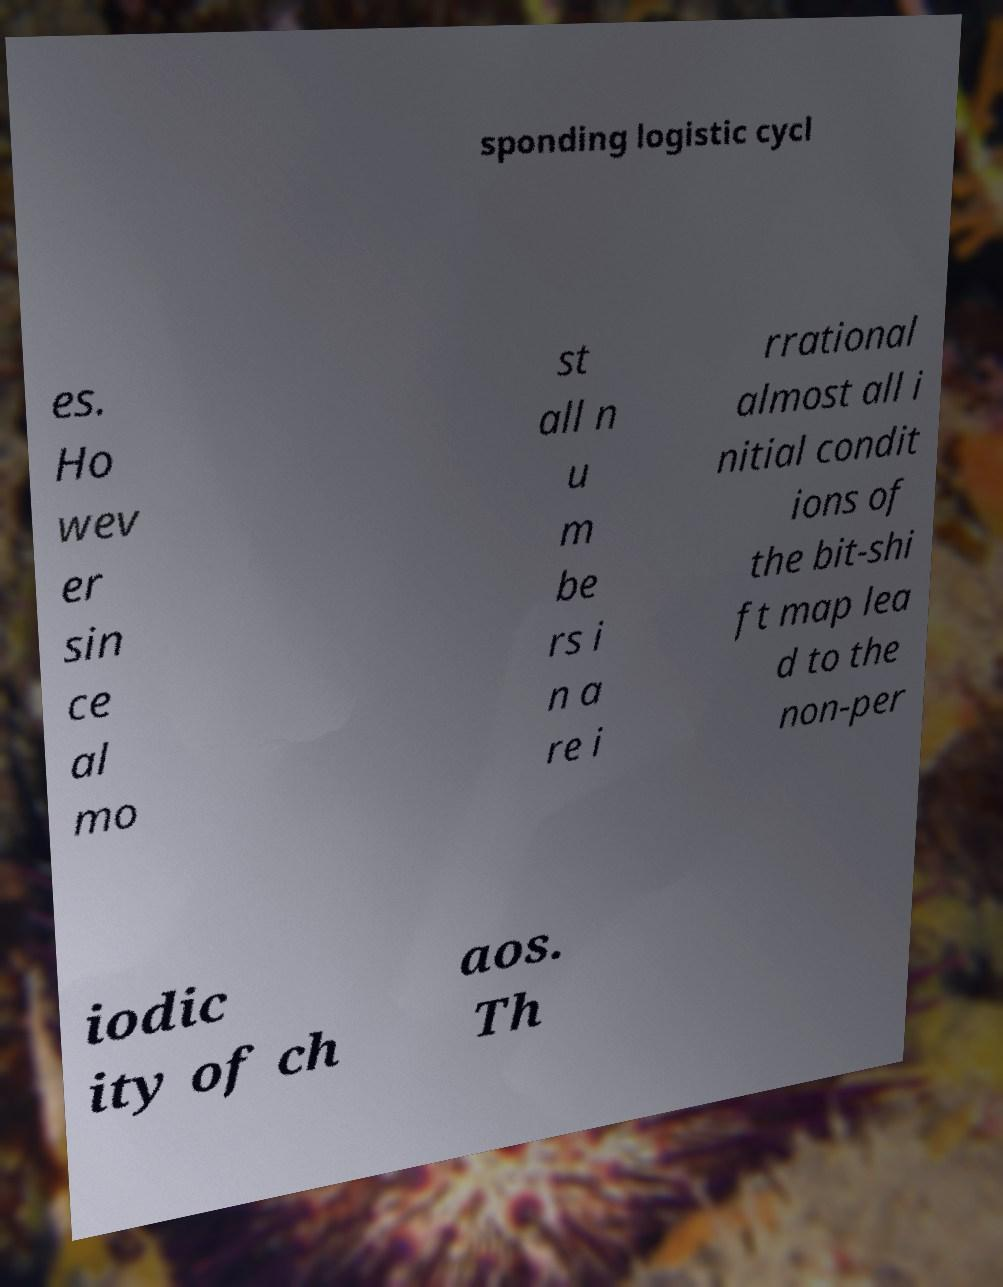Please read and relay the text visible in this image. What does it say? sponding logistic cycl es. Ho wev er sin ce al mo st all n u m be rs i n a re i rrational almost all i nitial condit ions of the bit-shi ft map lea d to the non-per iodic ity of ch aos. Th 